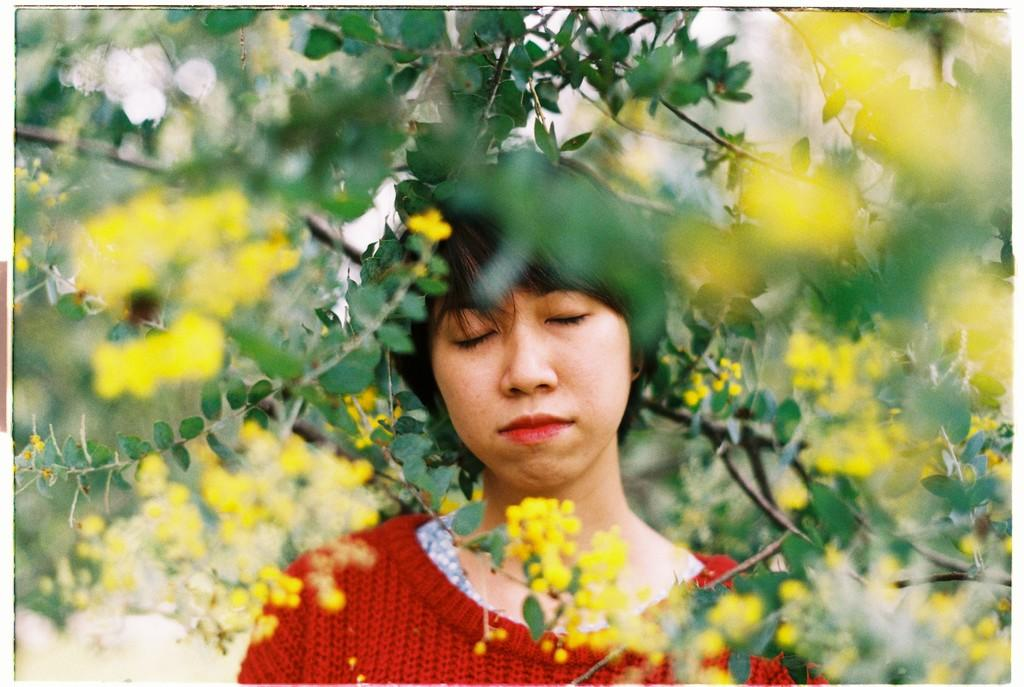Who is the main subject in the image? There is a woman in the image. What is the woman doing in the image? The woman is standing and closing her eyes. What is the woman wearing in the image? The woman is wearing a red color t-shirt. What type of natural elements can be seen in the image? There are trees and flowers visible in the image. How long does it take for the volcano to erupt in the image? There is no volcano present in the image, so it is not possible to determine how long it would take for it to erupt. 